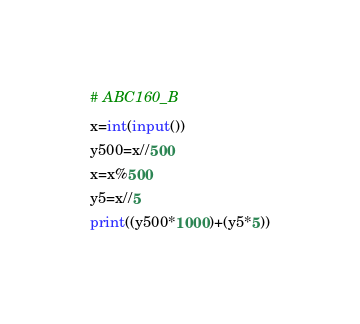Convert code to text. <code><loc_0><loc_0><loc_500><loc_500><_Python_># ABC160_B
x=int(input())
y500=x//500
x=x%500
y5=x//5
print((y500*1000)+(y5*5))</code> 